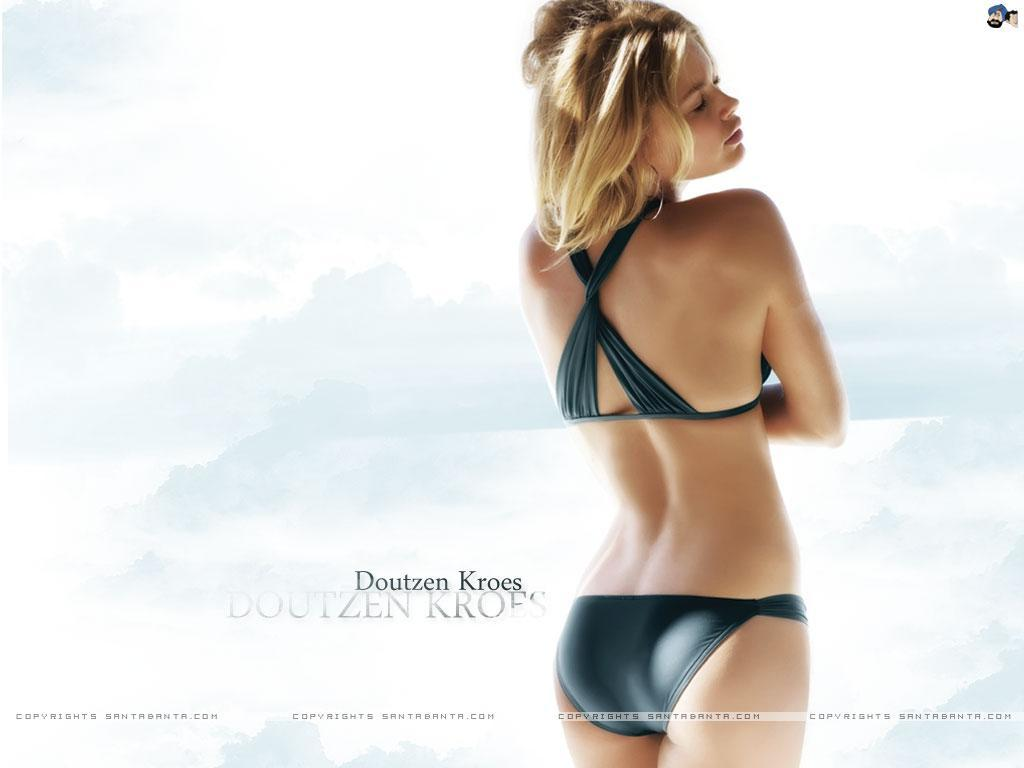What is the main subject of the image? There is a lady standing in the image. Can you describe any text present in the image? Yes, there is some text written on the left side of the image. What type of songs can be heard coming from the goat in the image? There is no goat present in the image, so it's not possible to determine what, if any, songs might be heard. 